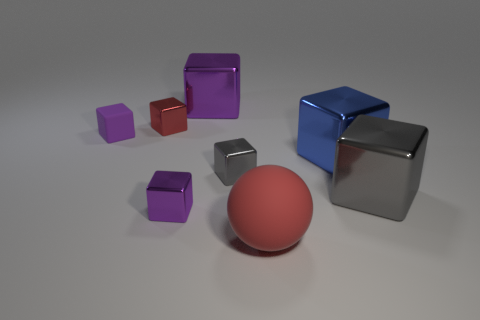Is the number of small red cubes less than the number of large yellow shiny cylinders?
Make the answer very short. No. There is a red thing that is the same size as the blue metal object; what is it made of?
Give a very brief answer. Rubber. What number of objects are either big purple objects or tiny purple objects?
Your answer should be very brief. 3. What number of shiny cubes are to the left of the big gray shiny object and in front of the big blue cube?
Ensure brevity in your answer.  2. Are there fewer objects behind the big blue metal block than purple metal blocks?
Provide a short and direct response. No. What is the shape of the rubber thing that is the same size as the blue cube?
Your answer should be very brief. Sphere. How many other things are there of the same color as the tiny rubber thing?
Make the answer very short. 2. Do the red rubber sphere and the blue object have the same size?
Keep it short and to the point. Yes. How many things are either metal blocks or small objects that are in front of the small matte cube?
Keep it short and to the point. 6. Is the number of big purple blocks that are left of the large purple shiny thing less than the number of large blocks that are to the left of the large blue metal block?
Keep it short and to the point. Yes. 